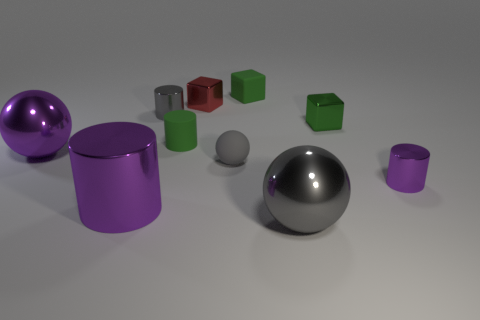Subtract 1 cylinders. How many cylinders are left? 3 Subtract all spheres. How many objects are left? 7 Add 5 green cubes. How many green cubes exist? 7 Subtract 0 green spheres. How many objects are left? 10 Subtract all rubber cubes. Subtract all big brown rubber balls. How many objects are left? 9 Add 9 tiny gray rubber balls. How many tiny gray rubber balls are left? 10 